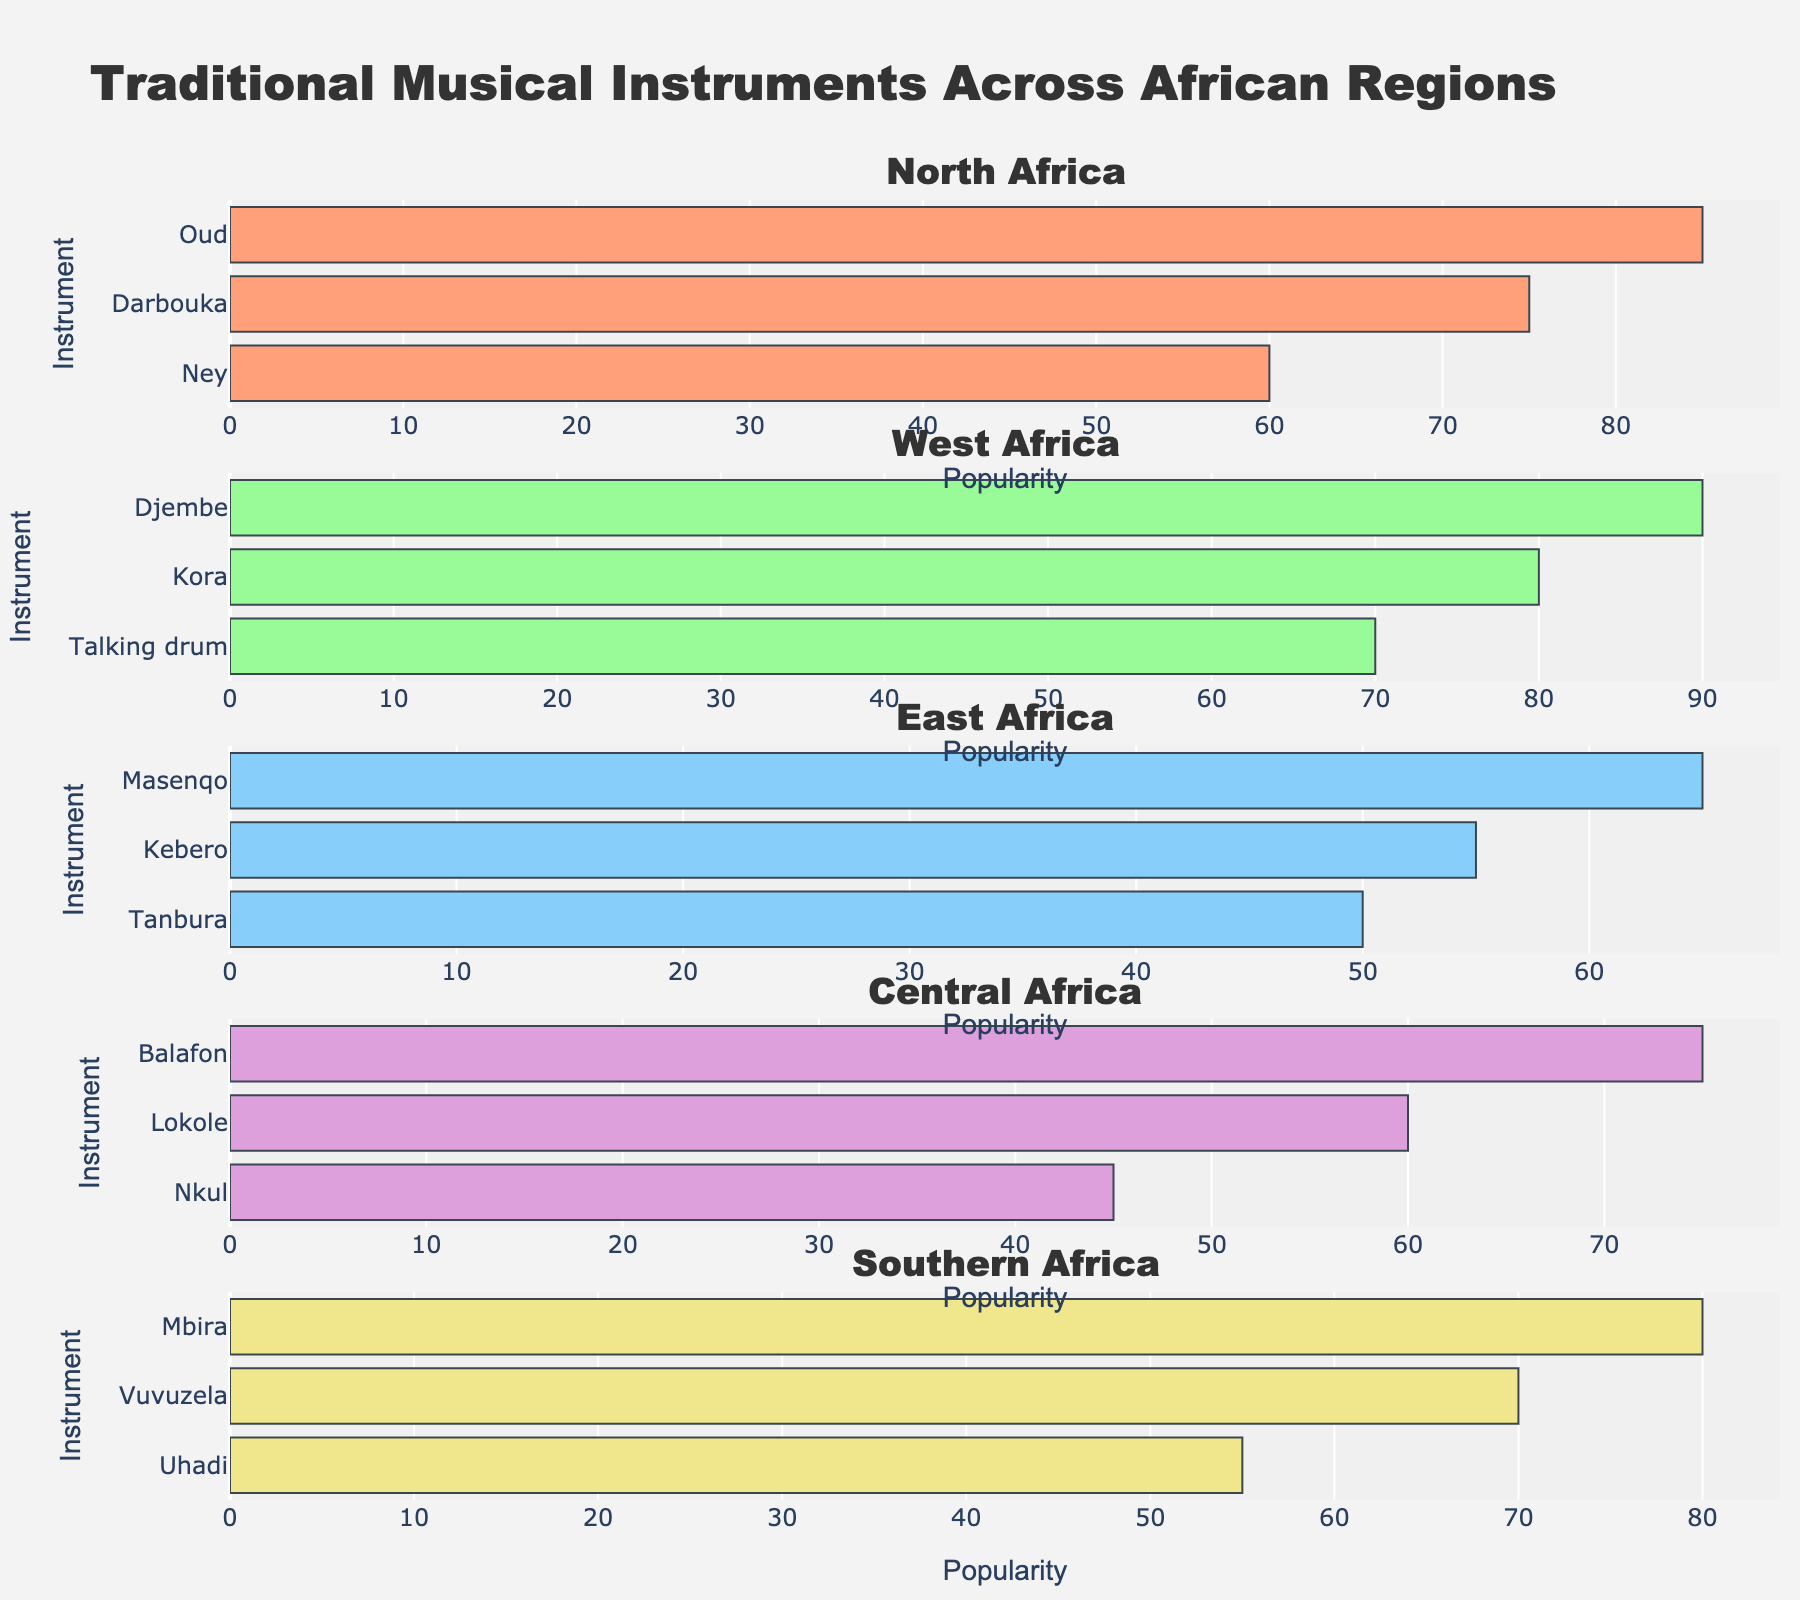What is the most popular instrument in West Africa? According to the figure, the Djembe has the highest popularity score in West Africa.
Answer: Djembe Which region features the instrument 'Mbira', and what is its popularity score? The instrument 'Mbira' is featured in the Southern Africa region with a popularity score of 80.
Answer: Southern Africa, 80 What is the least popular instrument in Central Africa? The instrument with the lowest popularity score in Central Africa is the Nkul, which has a popularity score of 45.
Answer: Nkul Which regions have 'instrument' popularity scores above 80? Both North Africa and West Africa have instruments with popularity scores above 80. In North Africa, it is the Oud with a score of 85, and in West Africa, it is the Djembe with a score of 90.
Answer: North Africa, West Africa Compare the popularity of 'Talking drum' and 'Masenqo'. Which one is more popular and by how much? The popularity of the 'Talking drum' in West Africa is 70, whereas the 'Masenqo' in East Africa has a score of 65. Therefore, the 'Talking drum' is more popular by 5 points.
Answer: Talking drum, 5 List all instruments with a popularity score of 70. The two instruments with a popularity score of 70 are the 'Talking drum' from West Africa and the 'Vuvuzela' from Southern Africa.
Answer: Talking drum, Vuvuzela Which region has the highest average popularity score for its instruments? To find the average, sum up the popularity scores for each region and divide by the number of instruments. For North Africa: (85 + 75 + 60)/3 = 73.33. For West Africa: (90 + 80 + 70)/3 = 80. For East Africa: (65 + 55 + 50)/3 = 56.67. For Central Africa: (75 + 60 + 45)/3 = 60. For Southern Africa: (80 + 70 + 55)/3 = 68.33. Therefore, the highest average is in West Africa, with an average score of 80.
Answer: West Africa How many different regions are present in the figure? The figure presents musical instruments from five regions: North Africa, West Africa, East Africa, Central Africa, and Southern Africa.
Answer: Five What is the difference in popularity between the 'Oud' from North Africa and the 'Balafon' from Central Africa? The popularity of the 'Oud' is 85, and the 'Balafon' is 75, giving a difference of 85 - 75 = 10.
Answer: 10 